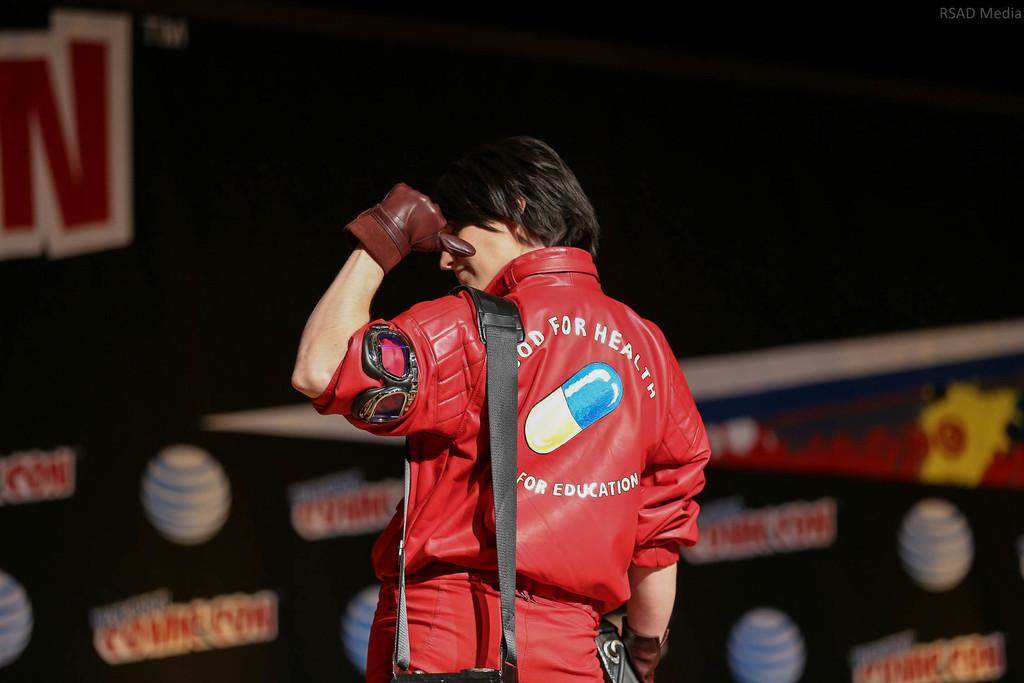<image>
Write a terse but informative summary of the picture. A man in a jacket that says Good For Health on the back. 